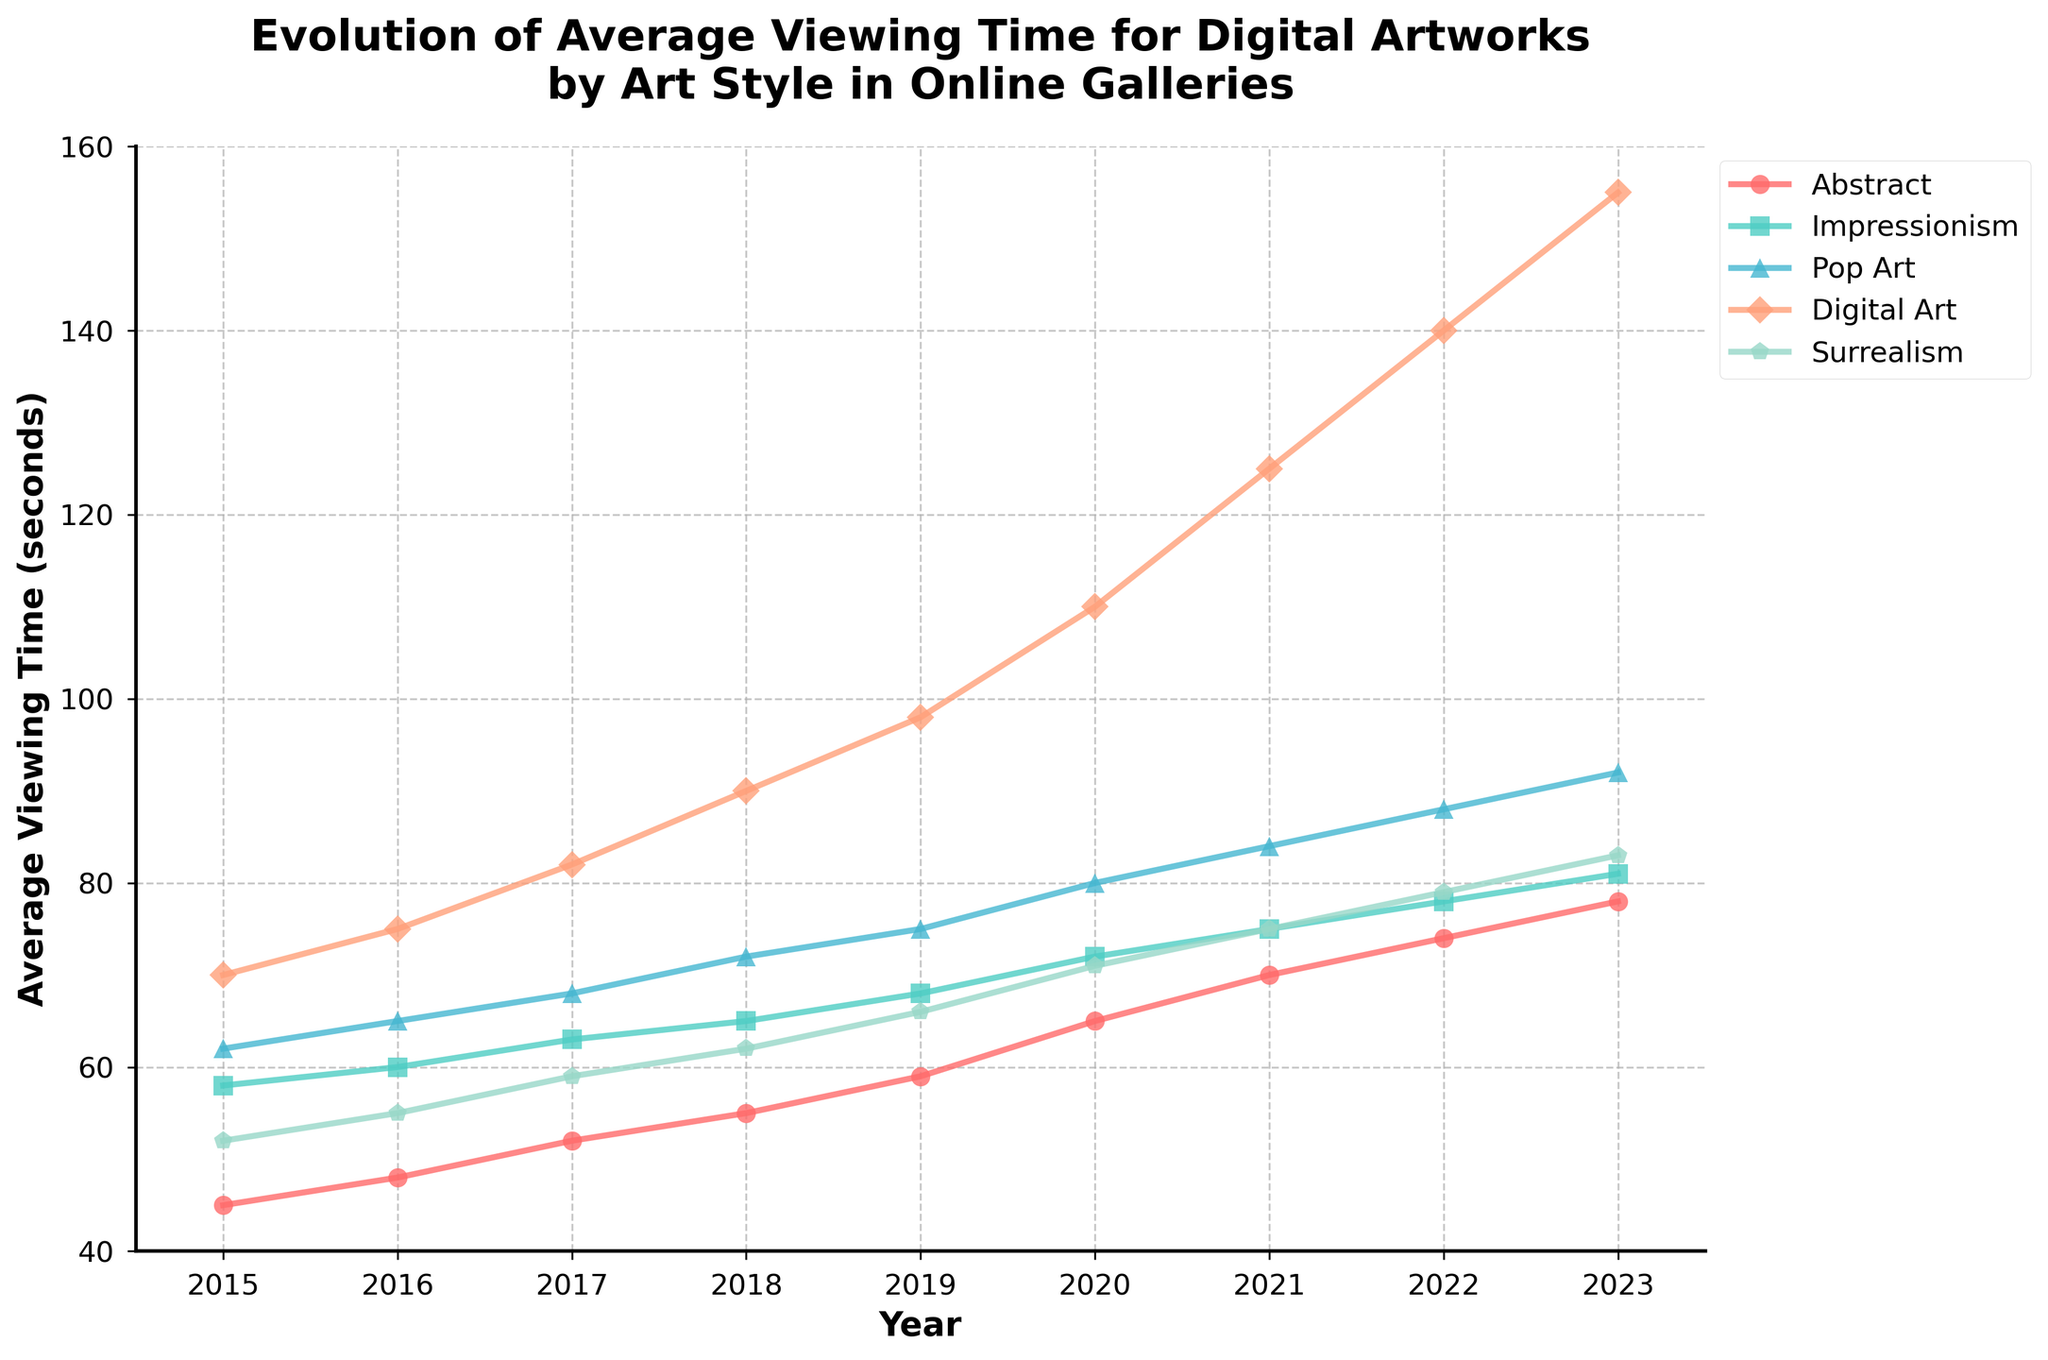What's the trend in average viewing time for Digital Art from 2015 to 2023? The plot shows the average viewing time increasing each year. Specifically, it goes from 70 seconds in 2015 to 155 seconds in 2023, indicating a steady upward trend.
Answer: Steady upward trend Which art style had the highest average viewing time in 2021? Look for the highest point in 2021. The Digital Art line is the highest in 2021 with an average viewing time of 125 seconds.
Answer: Digital Art How has the viewing time for Abstract art changed from 2015 to 2023? Observe the Abstract line from 2015 to 2023. The average viewing time increases from 45 seconds in 2015 to 78 seconds in 2023, indicating a gradual rise.
Answer: Increased from 45 to 78 seconds Between 2017 and 2019, which art style saw the largest increase in viewing time? Calculate the differences for each art style: Abstract (7s), Impressionism (5s), Pop Art (7s), Digital Art (16s), Surrealism (7s). Digital Art has the largest increase.
Answer: Digital Art Compare the average viewing time for Pop Art and Surrealism in 2022. Which is higher and by how much? Look at the values for Pop Art (88s) and Surrealism (79s) in 2022. Pop Art is higher by 88 - 79 = 9 seconds.
Answer: Pop Art by 9 seconds What is the average viewing time for Impressionism over the entire period? Sum Impressionism values: 58 + 60 + 63 + 65 + 68 + 72 + 75 + 78 + 81 = 620. Divide by 9 (number of years). Average = 620 / 9 ≈ 68.89.
Answer: 68.89 seconds In which year did Abstract art have viewing time equal or greater than 70 seconds? Check the Abstract trend. In 2022, the viewing time is 74 seconds, which is the first year it is >= 70.
Answer: 2022 Did any art style show a decline in viewing time at any point? Look at all lines. All styles show a consistent increase, with no decline in any year.
Answer: No What's the difference in average viewing time between Pop Art and Digital Art in 2020? Look at values in 2020: Pop Art (80s), Digital Art (110s). Difference = 110 - 80 = 30 seconds.
Answer: 30 seconds Compare the viewing times for Surrealism in 2015 and 2023. What is the percentage increase? Viewing times: 2015 (52s), 2023 (83s). Increase = 83 - 52 = 31 seconds. Percentage increase = (31 / 52) * 100 ≈ 59.62%.
Answer: 59.62% 